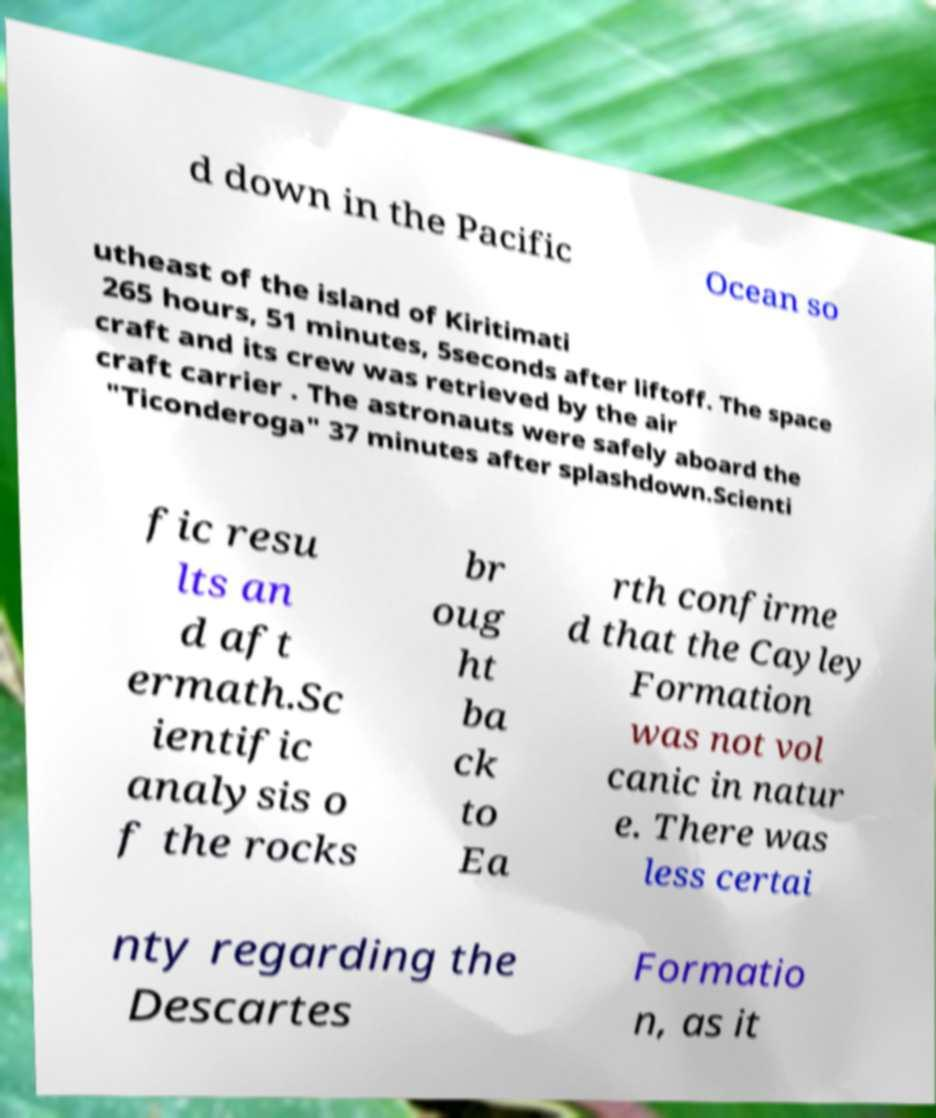Please read and relay the text visible in this image. What does it say? d down in the Pacific Ocean so utheast of the island of Kiritimati 265 hours, 51 minutes, 5seconds after liftoff. The space craft and its crew was retrieved by the air craft carrier . The astronauts were safely aboard the "Ticonderoga" 37 minutes after splashdown.Scienti fic resu lts an d aft ermath.Sc ientific analysis o f the rocks br oug ht ba ck to Ea rth confirme d that the Cayley Formation was not vol canic in natur e. There was less certai nty regarding the Descartes Formatio n, as it 